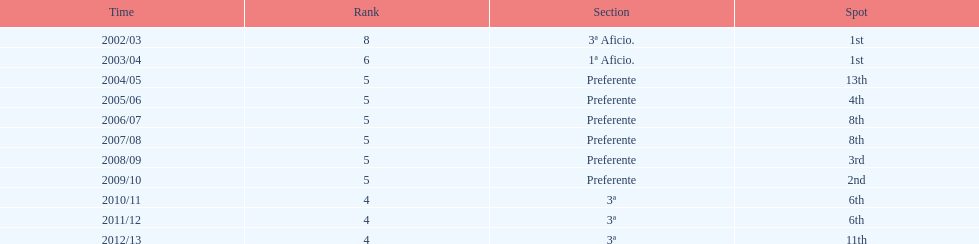How long did the team stay in first place? 2 years. 